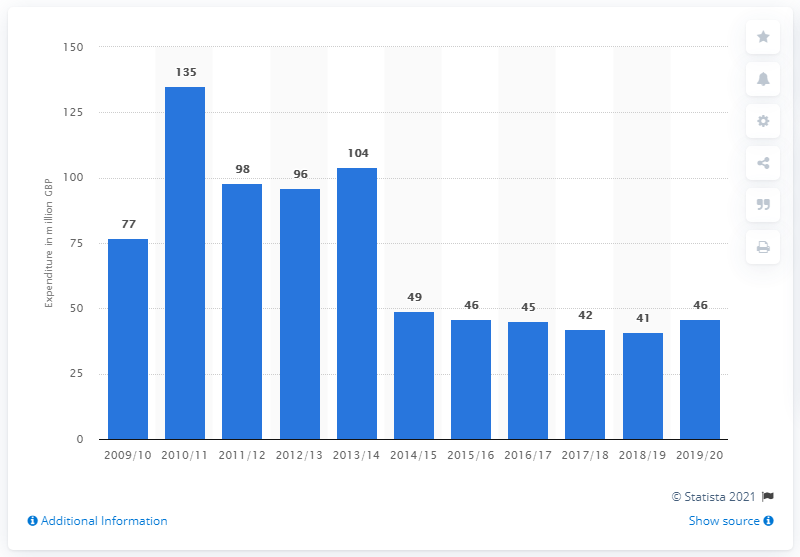Specify some key components in this picture. In the 2019/2020 fiscal year, the United Kingdom spent approximately 46 pounds on civil defense. 